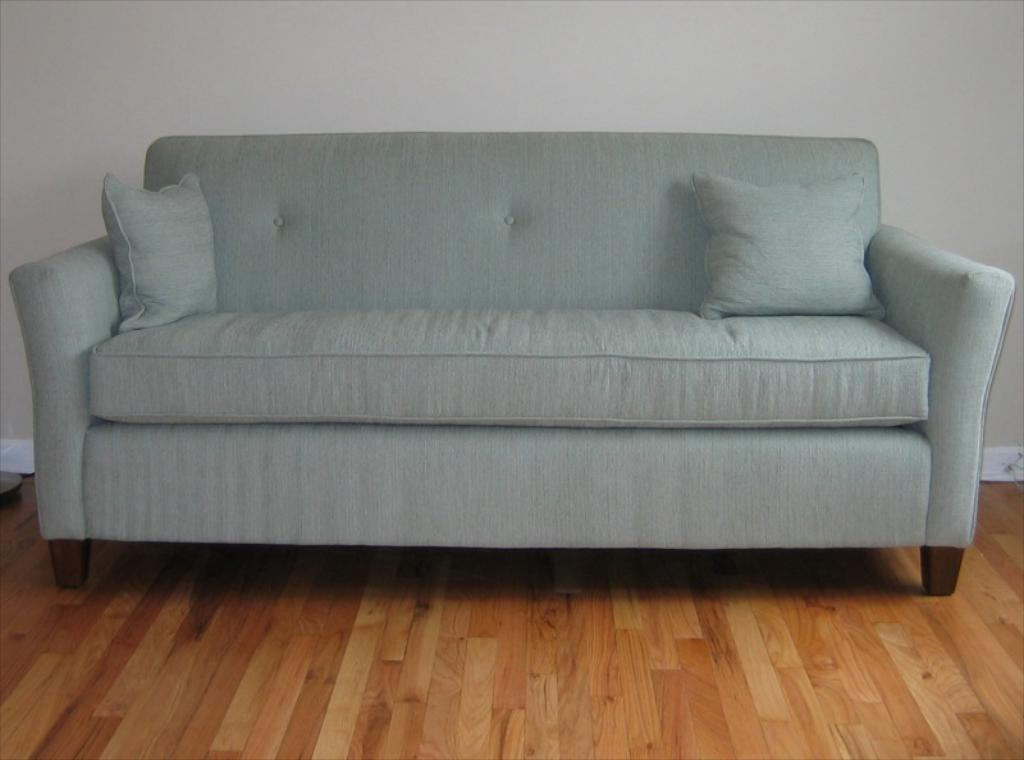What type of space is depicted in the image? There is a room in the image. What furniture can be seen in the room? There is a sofa in the room. What type of instrument is being played in the room? There is no instrument being played in the room, as the image only shows a room with a sofa. 